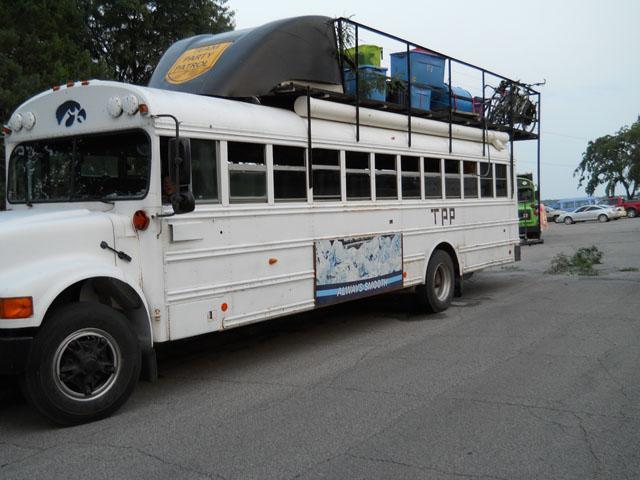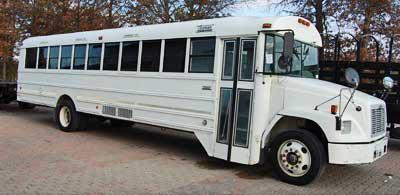The first image is the image on the left, the second image is the image on the right. Examine the images to the left and right. Is the description "One bus has objects on its roof." accurate? Answer yes or no. Yes. 